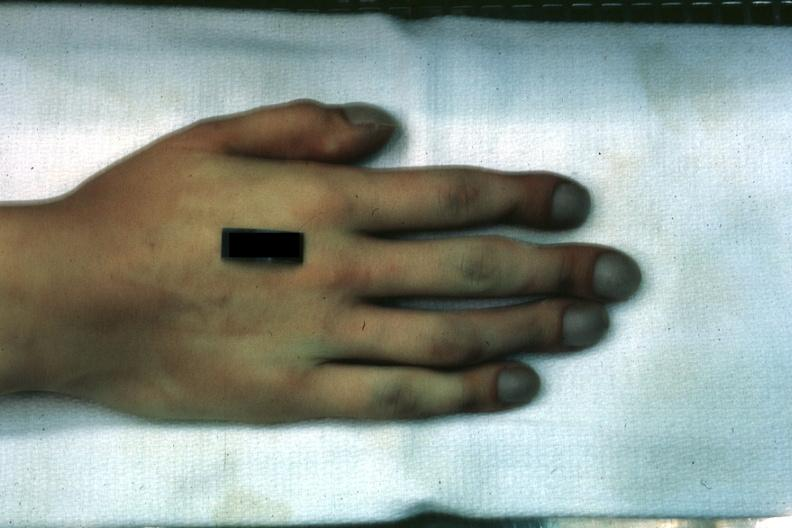s pulmonary osteoarthropathy present?
Answer the question using a single word or phrase. Yes 